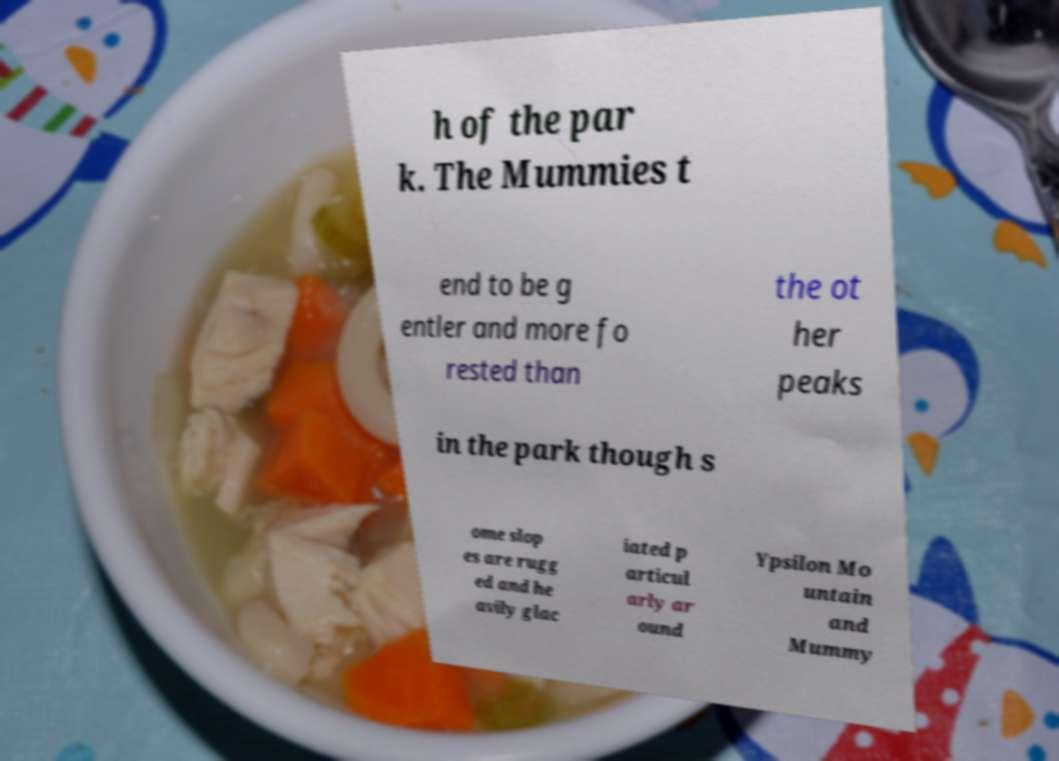Could you extract and type out the text from this image? h of the par k. The Mummies t end to be g entler and more fo rested than the ot her peaks in the park though s ome slop es are rugg ed and he avily glac iated p articul arly ar ound Ypsilon Mo untain and Mummy 